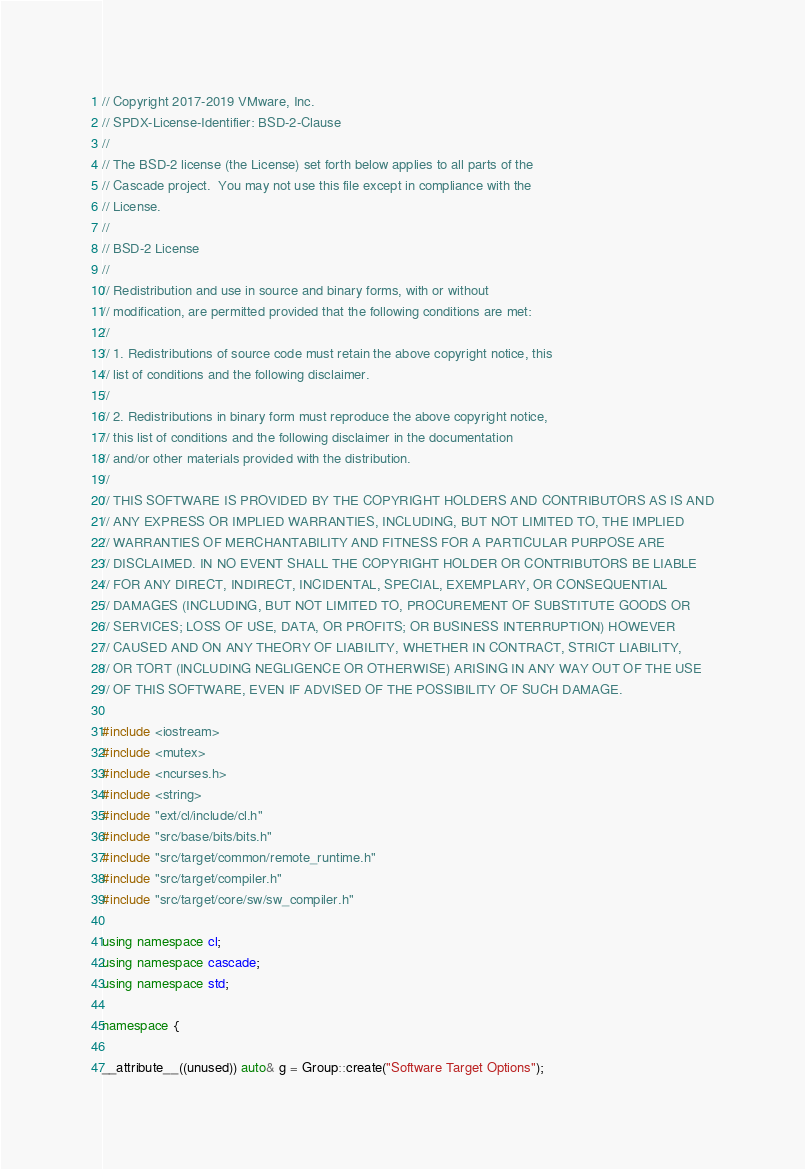Convert code to text. <code><loc_0><loc_0><loc_500><loc_500><_C++_>// Copyright 2017-2019 VMware, Inc.
// SPDX-License-Identifier: BSD-2-Clause
//
// The BSD-2 license (the License) set forth below applies to all parts of the
// Cascade project.  You may not use this file except in compliance with the
// License.
//
// BSD-2 License
//
// Redistribution and use in source and binary forms, with or without
// modification, are permitted provided that the following conditions are met:
//
// 1. Redistributions of source code must retain the above copyright notice, this
// list of conditions and the following disclaimer.
//
// 2. Redistributions in binary form must reproduce the above copyright notice,
// this list of conditions and the following disclaimer in the documentation
// and/or other materials provided with the distribution.
//
// THIS SOFTWARE IS PROVIDED BY THE COPYRIGHT HOLDERS AND CONTRIBUTORS AS IS AND
// ANY EXPRESS OR IMPLIED WARRANTIES, INCLUDING, BUT NOT LIMITED TO, THE IMPLIED
// WARRANTIES OF MERCHANTABILITY AND FITNESS FOR A PARTICULAR PURPOSE ARE
// DISCLAIMED. IN NO EVENT SHALL THE COPYRIGHT HOLDER OR CONTRIBUTORS BE LIABLE
// FOR ANY DIRECT, INDIRECT, INCIDENTAL, SPECIAL, EXEMPLARY, OR CONSEQUENTIAL
// DAMAGES (INCLUDING, BUT NOT LIMITED TO, PROCUREMENT OF SUBSTITUTE GOODS OR
// SERVICES; LOSS OF USE, DATA, OR PROFITS; OR BUSINESS INTERRUPTION) HOWEVER
// CAUSED AND ON ANY THEORY OF LIABILITY, WHETHER IN CONTRACT, STRICT LIABILITY,
// OR TORT (INCLUDING NEGLIGENCE OR OTHERWISE) ARISING IN ANY WAY OUT OF THE USE
// OF THIS SOFTWARE, EVEN IF ADVISED OF THE POSSIBILITY OF SUCH DAMAGE.

#include <iostream>
#include <mutex>
#include <ncurses.h>
#include <string>
#include "ext/cl/include/cl.h"
#include "src/base/bits/bits.h"
#include "src/target/common/remote_runtime.h"
#include "src/target/compiler.h"
#include "src/target/core/sw/sw_compiler.h"

using namespace cl;
using namespace cascade;
using namespace std;

namespace {
        
__attribute__((unused)) auto& g = Group::create("Software Target Options");</code> 